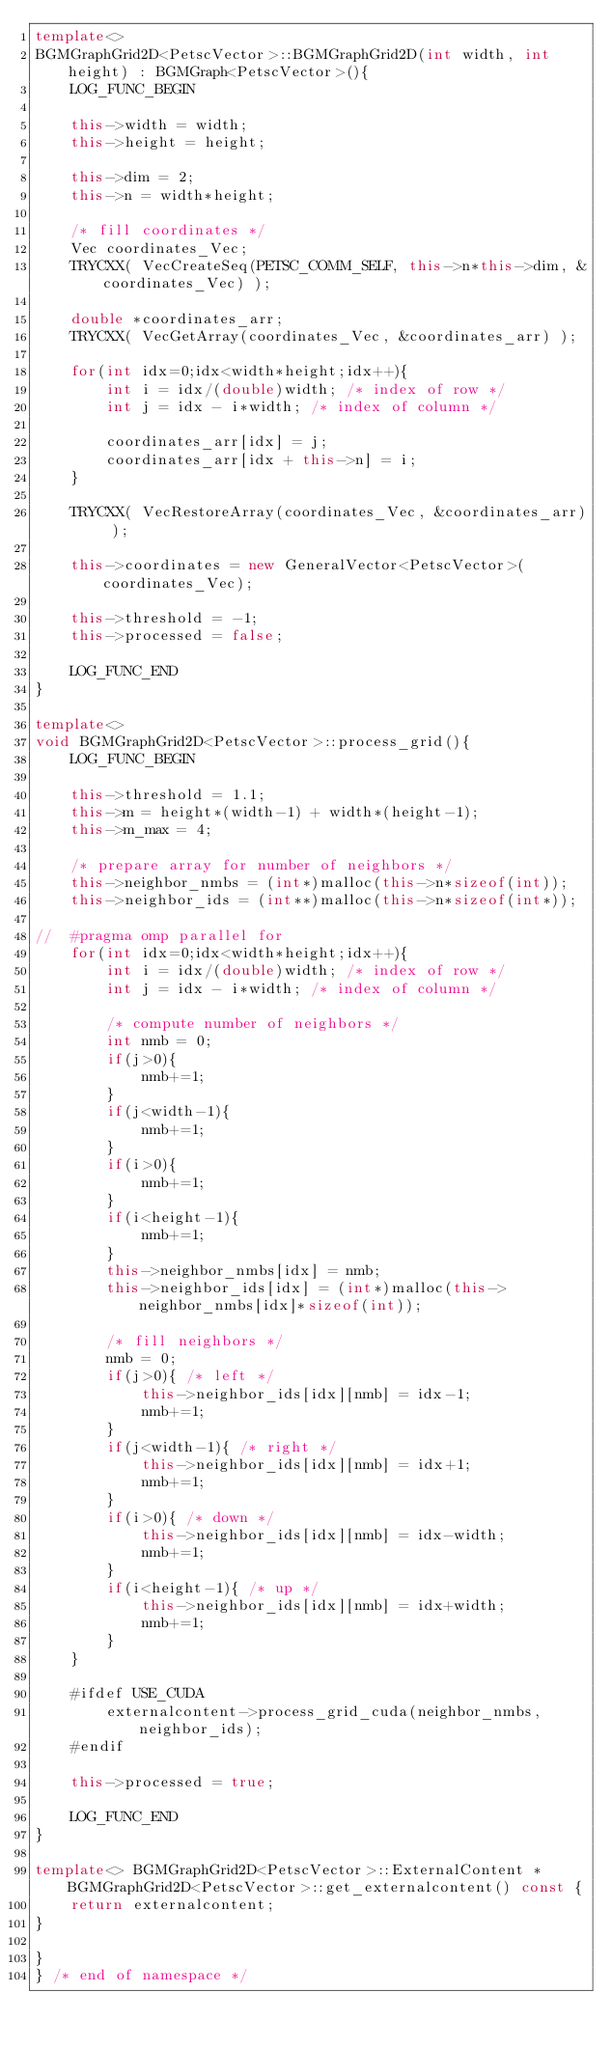<code> <loc_0><loc_0><loc_500><loc_500><_C++_>template<>
BGMGraphGrid2D<PetscVector>::BGMGraphGrid2D(int width, int height) : BGMGraph<PetscVector>(){
	LOG_FUNC_BEGIN

	this->width = width;
	this->height = height;

	this->dim = 2;
	this->n = width*height;
	
	/* fill coordinates */
	Vec coordinates_Vec;
	TRYCXX( VecCreateSeq(PETSC_COMM_SELF, this->n*this->dim, &coordinates_Vec) );
	
	double *coordinates_arr;
	TRYCXX( VecGetArray(coordinates_Vec, &coordinates_arr) );

	for(int idx=0;idx<width*height;idx++){
		int i = idx/(double)width; /* index of row */
		int j = idx - i*width; /* index of column */	

		coordinates_arr[idx] = j;
		coordinates_arr[idx + this->n] = i;
	}

	TRYCXX( VecRestoreArray(coordinates_Vec, &coordinates_arr) );
	
	this->coordinates = new GeneralVector<PetscVector>(coordinates_Vec);

	this->threshold = -1;
	this->processed = false;

	LOG_FUNC_END
}

template<>
void BGMGraphGrid2D<PetscVector>::process_grid(){
	LOG_FUNC_BEGIN

	this->threshold = 1.1;
	this->m = height*(width-1) + width*(height-1);
	this->m_max = 4;

	/* prepare array for number of neighbors */
	this->neighbor_nmbs = (int*)malloc(this->n*sizeof(int));
	this->neighbor_ids = (int**)malloc(this->n*sizeof(int*));

//	#pragma omp parallel for
	for(int idx=0;idx<width*height;idx++){
		int i = idx/(double)width; /* index of row */
		int j = idx - i*width; /* index of column */	

		/* compute number of neighbors */
		int nmb = 0;
		if(j>0){
			nmb+=1;				
		}
		if(j<width-1){
			nmb+=1;				
		}
		if(i>0){
			nmb+=1;				
		}
		if(i<height-1){
			nmb+=1;				
		}
		this->neighbor_nmbs[idx] = nmb;
		this->neighbor_ids[idx] = (int*)malloc(this->neighbor_nmbs[idx]*sizeof(int));
			
		/* fill neighbors */
		nmb = 0;
		if(j>0){ /* left */
			this->neighbor_ids[idx][nmb] = idx-1;
			nmb+=1;	
		}
		if(j<width-1){ /* right */
			this->neighbor_ids[idx][nmb] = idx+1;
			nmb+=1;	
		}
		if(i>0){ /* down */
			this->neighbor_ids[idx][nmb] = idx-width;
			nmb+=1;	
		}
		if(i<height-1){ /* up */
			this->neighbor_ids[idx][nmb] = idx+width;
			nmb+=1;	
		}
	}

	#ifdef USE_CUDA
		externalcontent->process_grid_cuda(neighbor_nmbs, neighbor_ids);
	#endif
	
	this->processed = true;

	LOG_FUNC_END
}

template<> BGMGraphGrid2D<PetscVector>::ExternalContent * BGMGraphGrid2D<PetscVector>::get_externalcontent() const {
	return externalcontent;
}

}
} /* end of namespace */
</code> 